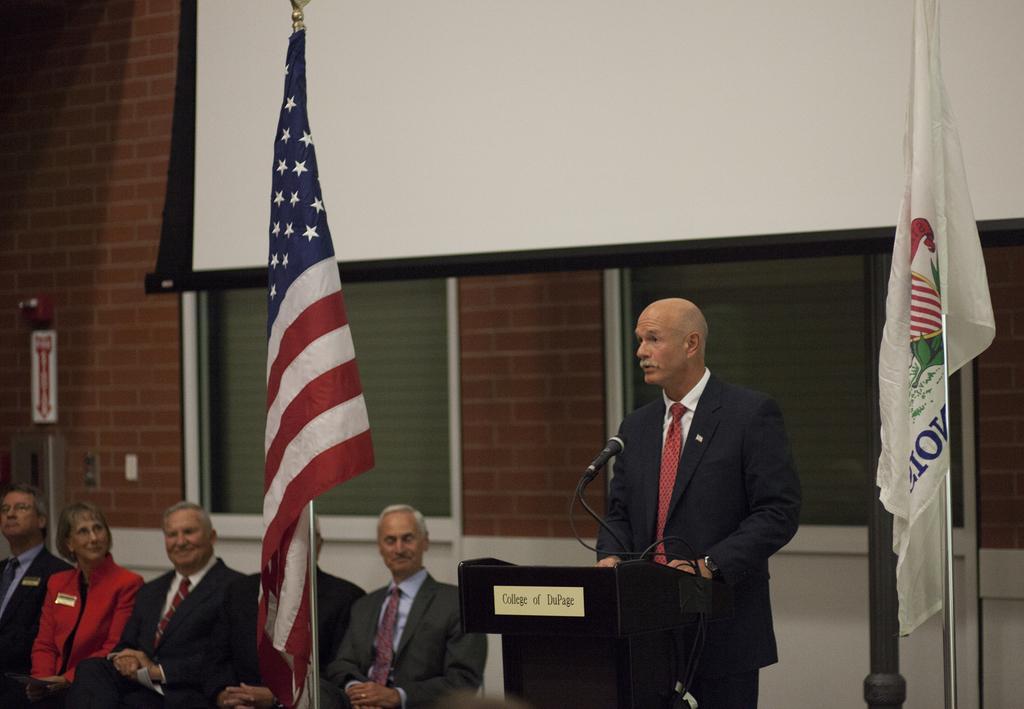Describe this image in one or two sentences. In this image, we can see flags, rods, and person standing behind the podium. In-front of him there is a microphone with wire and rod. On the podium, we can see a board with text. At the bottom of the image, we can see people are sitting. In the background, there is a wall, door, screen and few objects. 